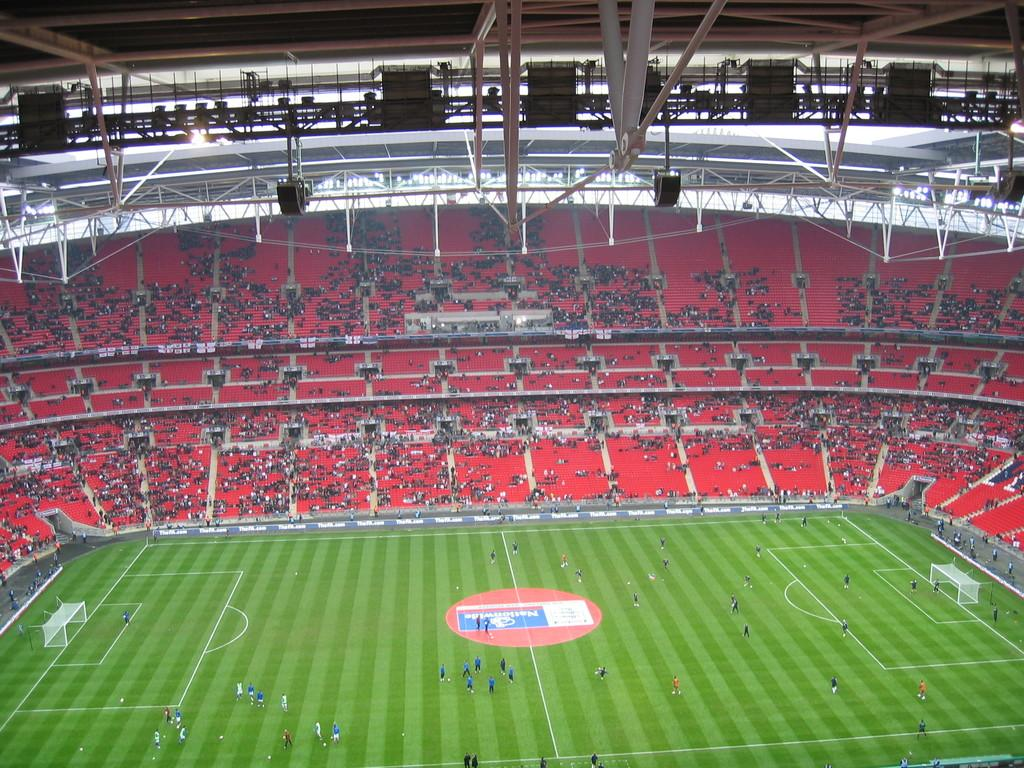What type of venue is depicted in the image? The image appears to be a football stadium. What is happening on the field in the image? There are players on the ground in the image. Who is present in the image besides the players? There is an audience in the image. What are the goal posts used for in the game? The goal posts are visible in the image and are used to score points. What is the weight of the picture hanging on the wall in the image? There is no picture hanging on the wall in the image; it is a football stadium with players, an audience, and goal posts. 